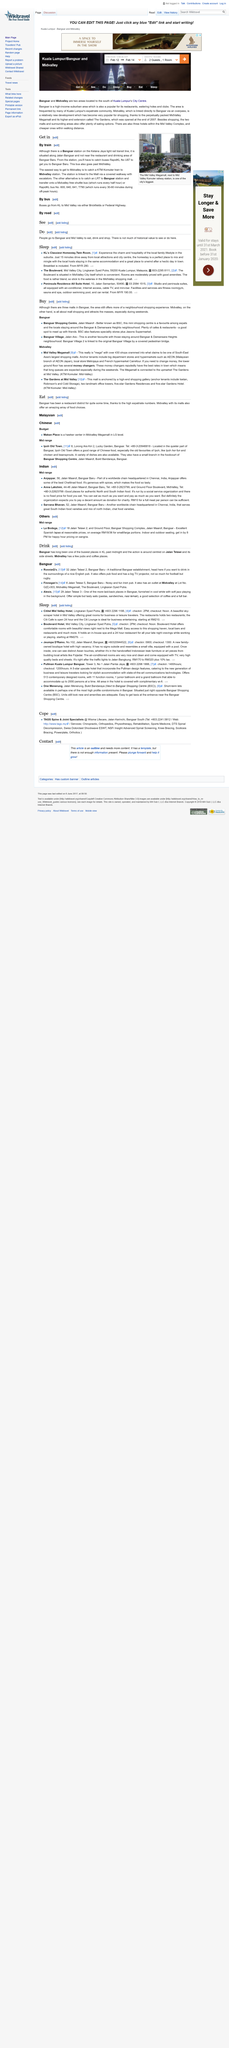Identify some key points in this picture. To access Bangsar Baru, one must board RapidKL Bus No U87 from the Bangsar station. The image depicts The Mid Valley Megamall, a building located in an unknown location. The quickest method of reaching Midvalley is by taking a KTM Komuter train from Midvalley station. 